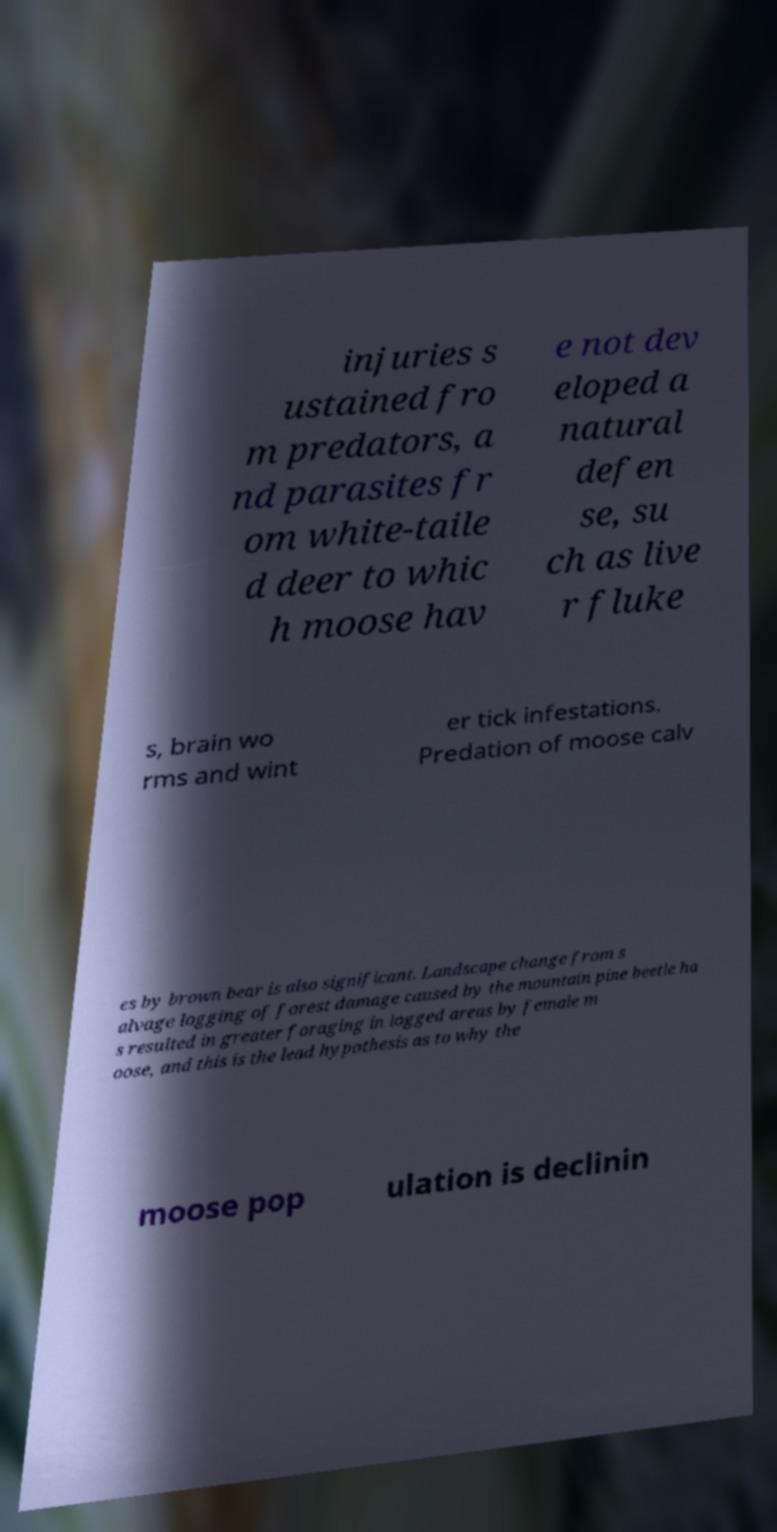Please read and relay the text visible in this image. What does it say? injuries s ustained fro m predators, a nd parasites fr om white-taile d deer to whic h moose hav e not dev eloped a natural defen se, su ch as live r fluke s, brain wo rms and wint er tick infestations. Predation of moose calv es by brown bear is also significant. Landscape change from s alvage logging of forest damage caused by the mountain pine beetle ha s resulted in greater foraging in logged areas by female m oose, and this is the lead hypothesis as to why the moose pop ulation is declinin 